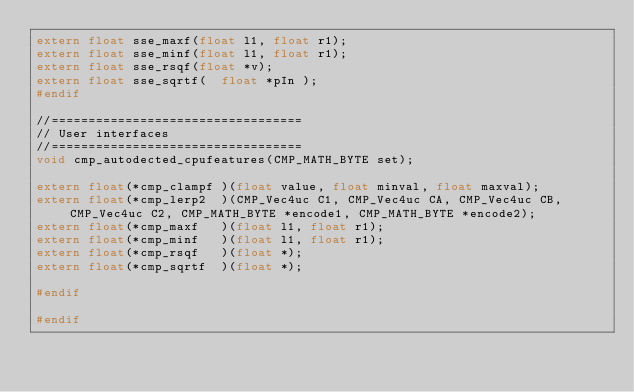Convert code to text. <code><loc_0><loc_0><loc_500><loc_500><_C_>extern float sse_maxf(float l1, float r1);
extern float sse_minf(float l1, float r1);
extern float sse_rsqf(float *v);
extern float sse_sqrtf(  float *pIn );
#endif

//==================================
// User interfaces
//==================================
void cmp_autodected_cpufeatures(CMP_MATH_BYTE set);

extern float(*cmp_clampf )(float value, float minval, float maxval);
extern float(*cmp_lerp2  )(CMP_Vec4uc C1, CMP_Vec4uc CA, CMP_Vec4uc CB, CMP_Vec4uc C2, CMP_MATH_BYTE *encode1, CMP_MATH_BYTE *encode2);
extern float(*cmp_maxf   )(float l1, float r1);
extern float(*cmp_minf   )(float l1, float r1);
extern float(*cmp_rsqf   )(float *);
extern float(*cmp_sqrtf  )(float *);

#endif

#endif
</code> 